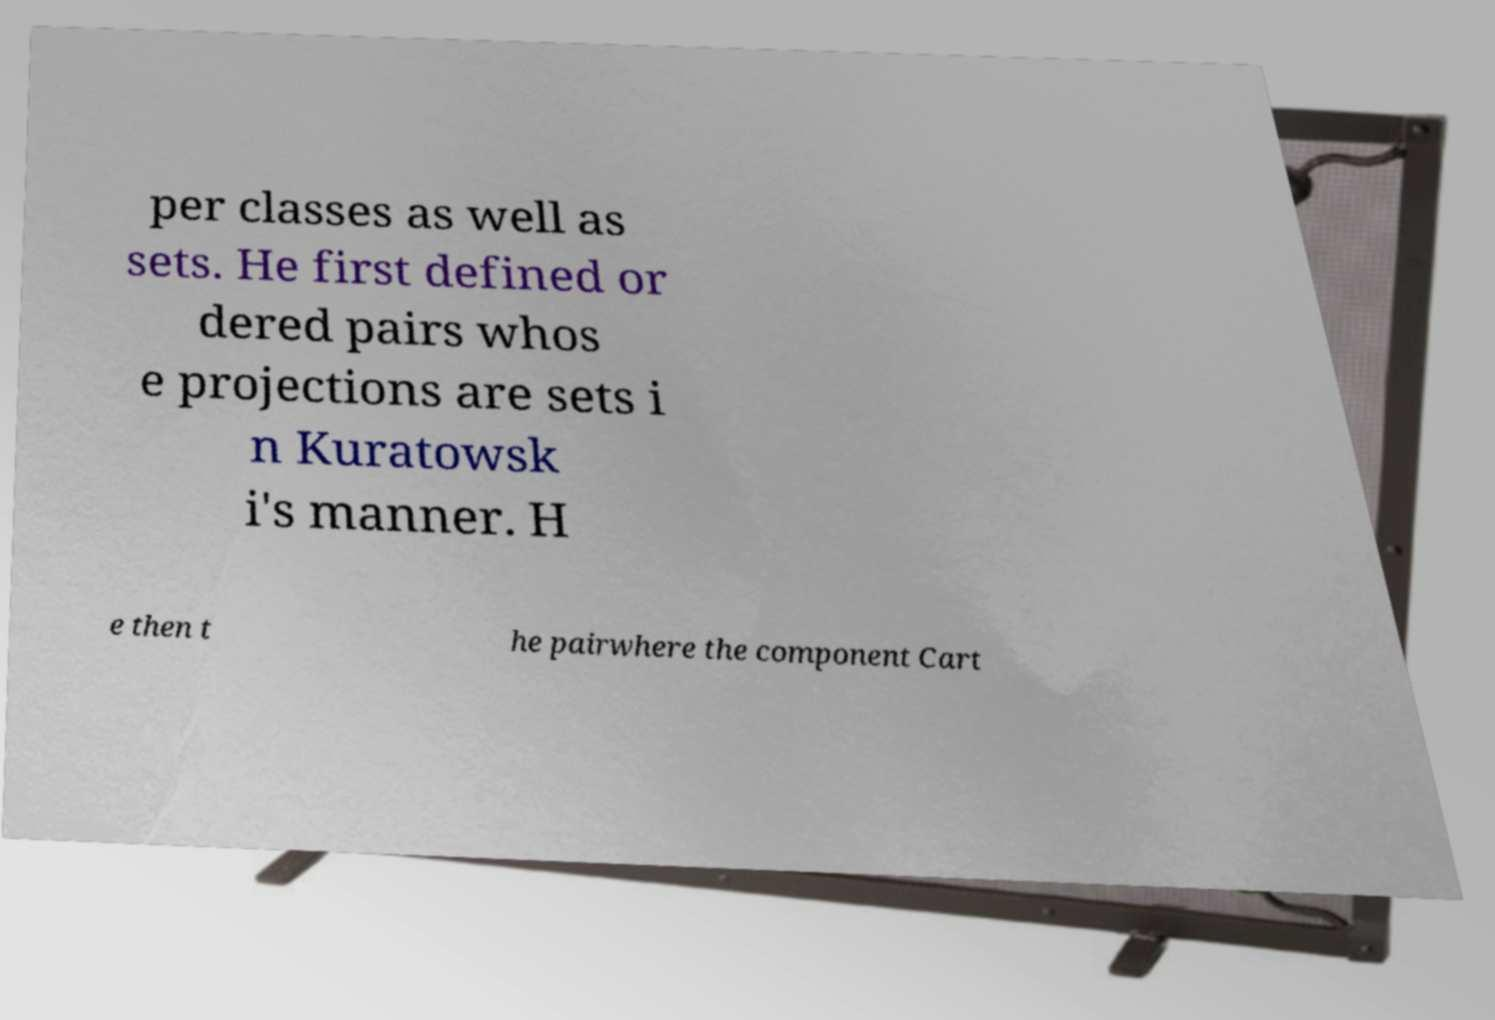There's text embedded in this image that I need extracted. Can you transcribe it verbatim? per classes as well as sets. He first defined or dered pairs whos e projections are sets i n Kuratowsk i's manner. H e then t he pairwhere the component Cart 